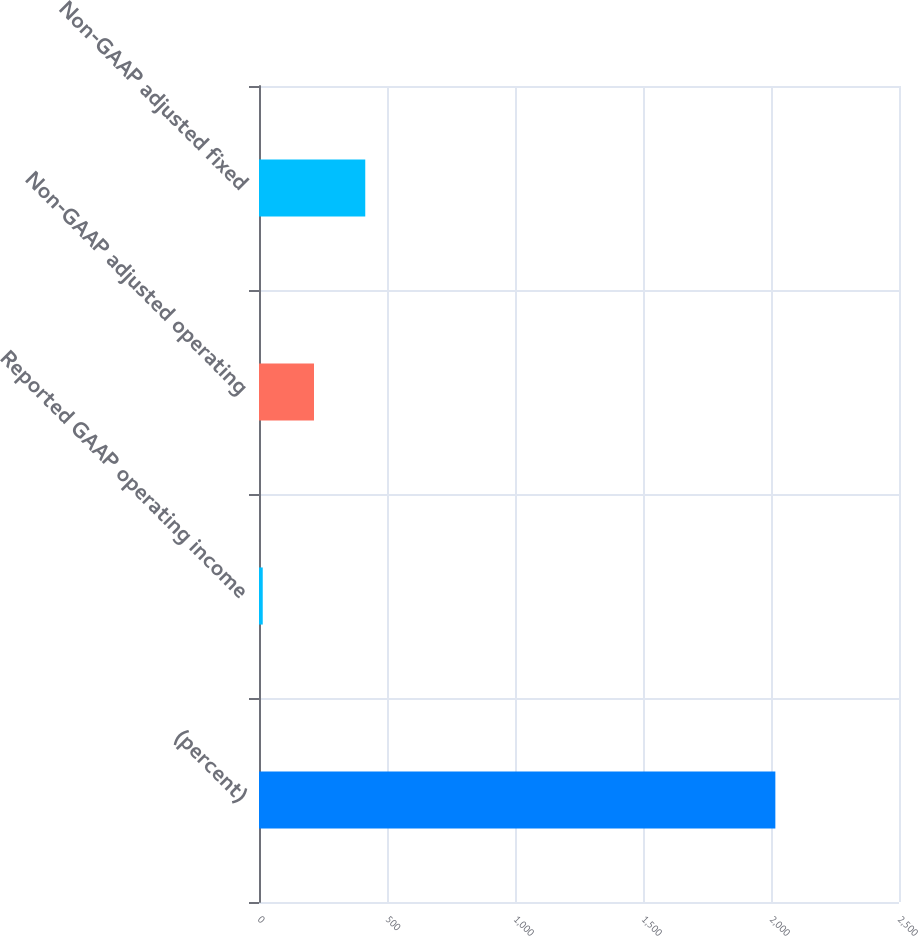Convert chart. <chart><loc_0><loc_0><loc_500><loc_500><bar_chart><fcel>(percent)<fcel>Reported GAAP operating income<fcel>Non-GAAP adjusted operating<fcel>Non-GAAP adjusted fixed<nl><fcel>2017<fcel>14.6<fcel>214.84<fcel>415.08<nl></chart> 